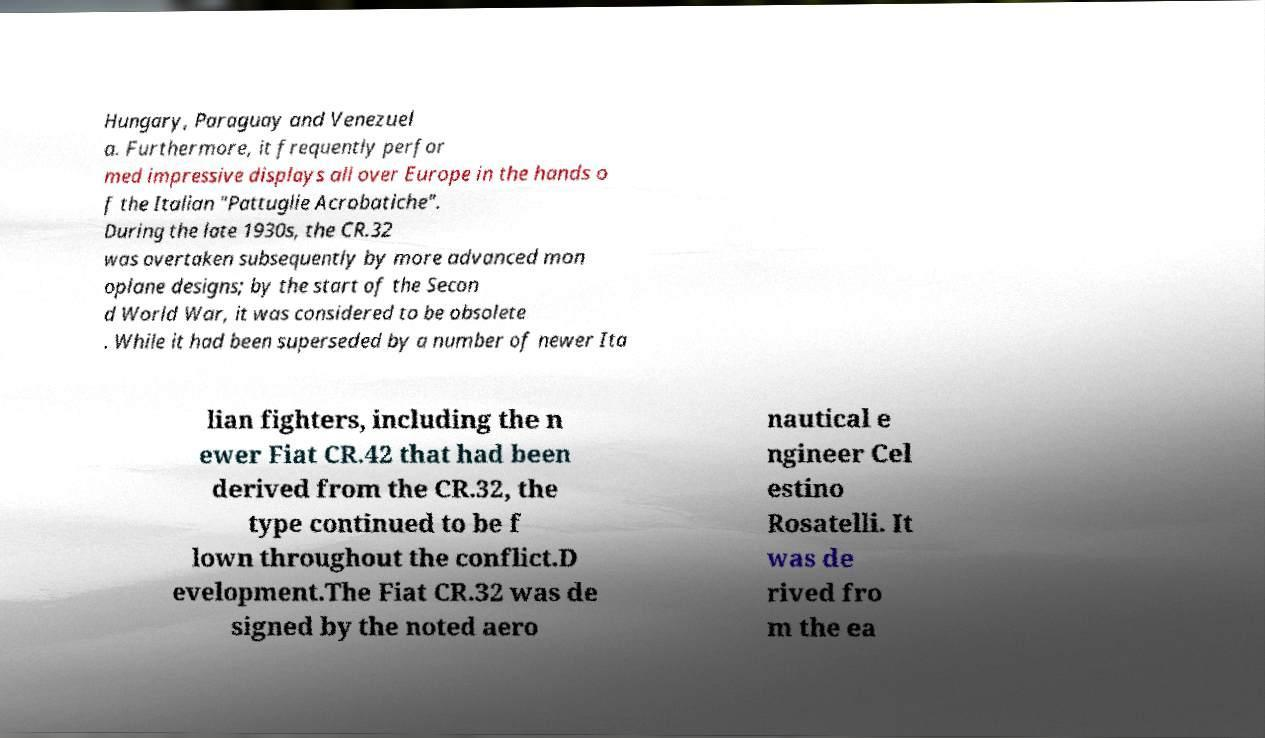What messages or text are displayed in this image? I need them in a readable, typed format. Hungary, Paraguay and Venezuel a. Furthermore, it frequently perfor med impressive displays all over Europe in the hands o f the Italian "Pattuglie Acrobatiche". During the late 1930s, the CR.32 was overtaken subsequently by more advanced mon oplane designs; by the start of the Secon d World War, it was considered to be obsolete . While it had been superseded by a number of newer Ita lian fighters, including the n ewer Fiat CR.42 that had been derived from the CR.32, the type continued to be f lown throughout the conflict.D evelopment.The Fiat CR.32 was de signed by the noted aero nautical e ngineer Cel estino Rosatelli. It was de rived fro m the ea 